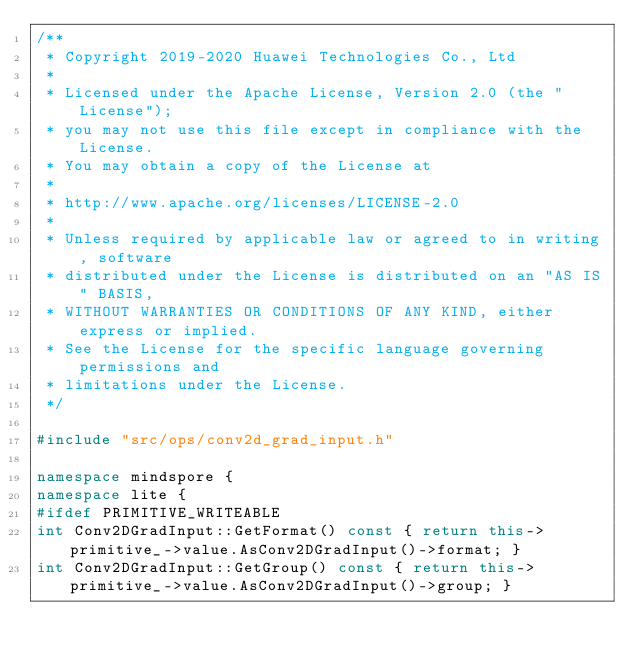Convert code to text. <code><loc_0><loc_0><loc_500><loc_500><_C++_>/**
 * Copyright 2019-2020 Huawei Technologies Co., Ltd
 *
 * Licensed under the Apache License, Version 2.0 (the "License");
 * you may not use this file except in compliance with the License.
 * You may obtain a copy of the License at
 *
 * http://www.apache.org/licenses/LICENSE-2.0
 *
 * Unless required by applicable law or agreed to in writing, software
 * distributed under the License is distributed on an "AS IS" BASIS,
 * WITHOUT WARRANTIES OR CONDITIONS OF ANY KIND, either express or implied.
 * See the License for the specific language governing permissions and
 * limitations under the License.
 */

#include "src/ops/conv2d_grad_input.h"

namespace mindspore {
namespace lite {
#ifdef PRIMITIVE_WRITEABLE
int Conv2DGradInput::GetFormat() const { return this->primitive_->value.AsConv2DGradInput()->format; }
int Conv2DGradInput::GetGroup() const { return this->primitive_->value.AsConv2DGradInput()->group; }</code> 